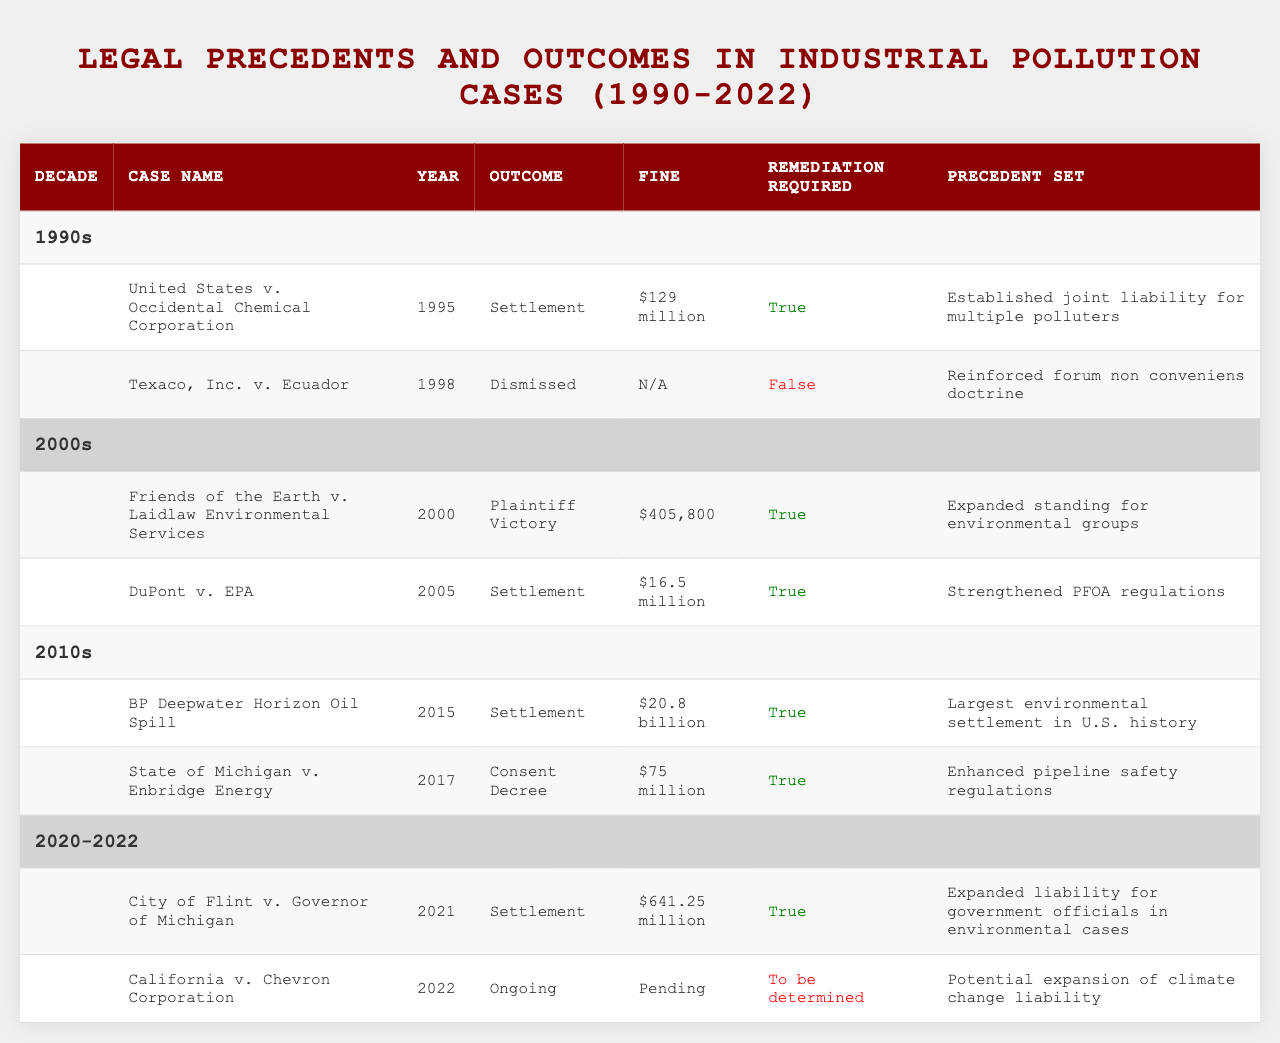What was the outcome of the case "United States v. Occidental Chemical Corporation"? The table lists that the outcome for this case was "Settlement."
Answer: Settlement How many cases required remediation in the 2010s? In the 2010s, both recorded cases, "BP Deepwater Horizon Oil Spill" and "State of Michigan v. Enbridge Energy," required remediation, totaling 2 cases.
Answer: 2 What was the fine imposed in the case "Friends of the Earth v. Laidlaw Environmental Services"? The table indicates that the fine imposed in this case was "$405,800."
Answer: $405,800 Is there an ongoing case in the table, and if so, which one? Yes, the case "California v. Chevron Corporation" is listed as ongoing.
Answer: California v. Chevron Corporation Which decade had the highest fine in a single case, and what was that fine? The decade of the 2010s had the highest fine of "$20.8 billion" for the case "BP Deepwater Horizon Oil Spill."
Answer: 2010s, $20.8 billion What precedent was set by the case "Texaco, Inc. v. Ecuador"? The table states that this case reinforced the forum non conveniens doctrine.
Answer: Reinforced forum non conveniens doctrine In how many cases was joint liability for multiple polluters established as a precedent? There is only one case in the 1990s, "United States v. Occidental Chemical Corporation," where joint liability was established as a precedent.
Answer: 1 What is the total amount of fines from all cases in the 2000s? The fines from the 2000s are $405,800 from "Friends of the Earth v. Laidlaw Environmental Services" and $16.5 million from "DuPont v. EPA," adding up to $16,905,800.
Answer: $16,905,800 In the 2020-2022 period, what is the status of the "California v. Chevron Corporation" case? The table indicates that the status of this case is "Ongoing."
Answer: Ongoing Did any case in the dataset not require remediation, and if so, which one? Yes, the case "Texaco, Inc. v. Ecuador" did not require remediation according to the table.
Answer: Texaco, Inc. v. Ecuador What percentage of cases in the 1990s involved a fine? In the 1990s, 1 out of 2 cases involved a fine. This gives a percentage of (1/2) * 100 = 50%.
Answer: 50% 